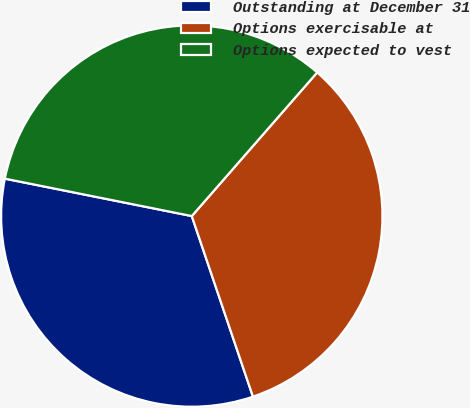Convert chart. <chart><loc_0><loc_0><loc_500><loc_500><pie_chart><fcel>Outstanding at December 31<fcel>Options exercisable at<fcel>Options expected to vest<nl><fcel>33.34%<fcel>33.38%<fcel>33.28%<nl></chart> 